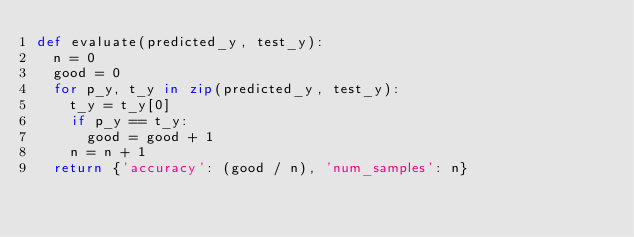Convert code to text. <code><loc_0><loc_0><loc_500><loc_500><_Python_>def evaluate(predicted_y, test_y):
  n = 0
  good = 0
  for p_y, t_y in zip(predicted_y, test_y):
    t_y = t_y[0]
    if p_y == t_y:
      good = good + 1
    n = n + 1
  return {'accuracy': (good / n), 'num_samples': n}
</code> 